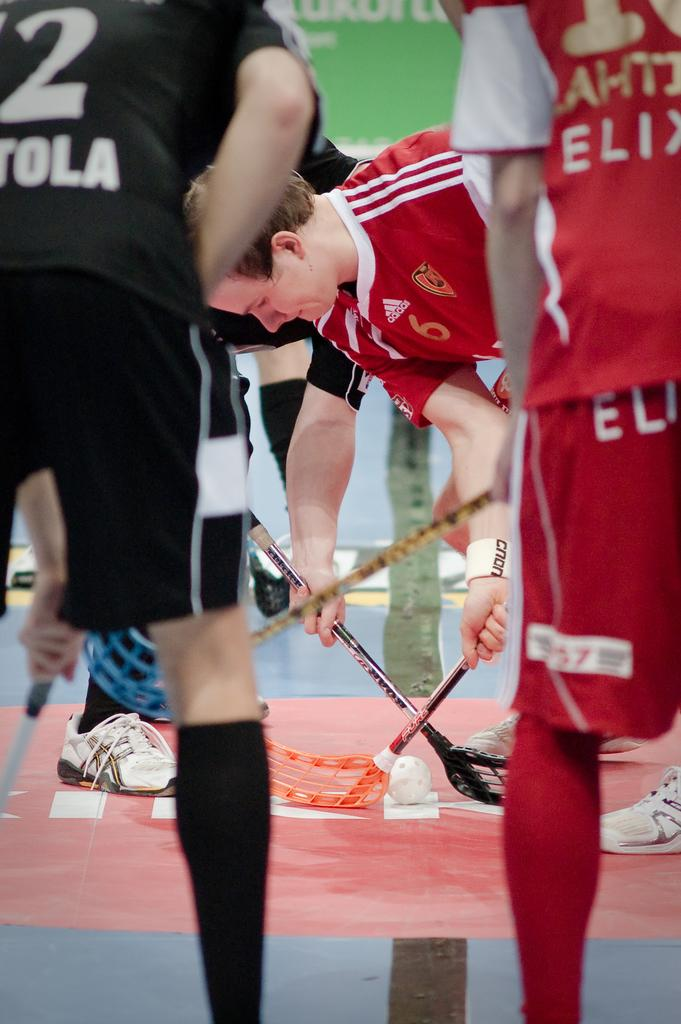<image>
Offer a succinct explanation of the picture presented. The red jersey was made by the Adidas clothing company. 